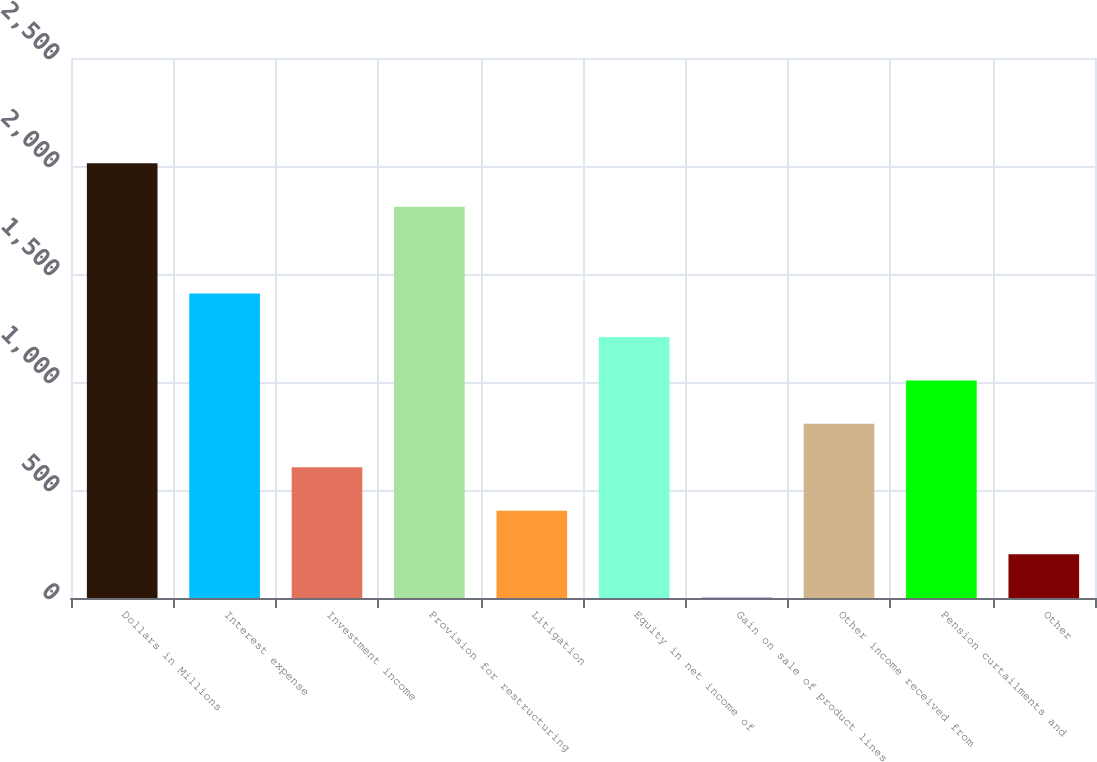Convert chart. <chart><loc_0><loc_0><loc_500><loc_500><bar_chart><fcel>Dollars in Millions<fcel>Interest expense<fcel>Investment income<fcel>Provision for restructuring<fcel>Litigation<fcel>Equity in net income of<fcel>Gain on sale of product lines<fcel>Other income received from<fcel>Pension curtailments and<fcel>Other<nl><fcel>2013<fcel>1409.7<fcel>605.3<fcel>1811.9<fcel>404.2<fcel>1208.6<fcel>2<fcel>806.4<fcel>1007.5<fcel>203.1<nl></chart> 